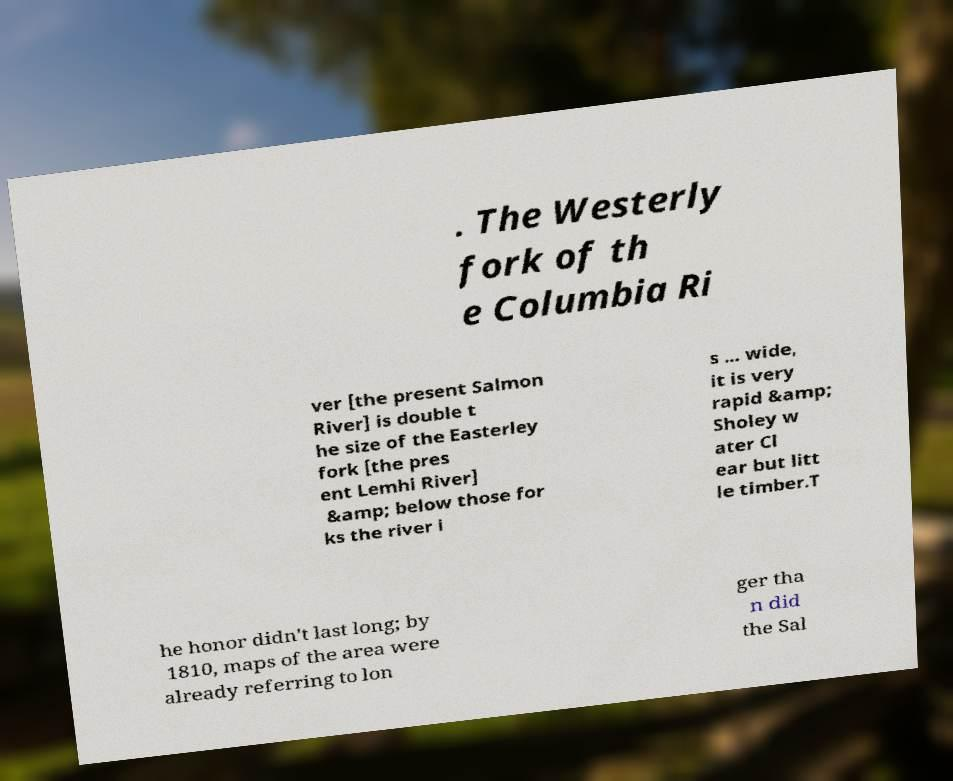Could you assist in decoding the text presented in this image and type it out clearly? . The Westerly fork of th e Columbia Ri ver [the present Salmon River] is double t he size of the Easterley fork [the pres ent Lemhi River] &amp; below those for ks the river i s ... wide, it is very rapid &amp; Sholey w ater Cl ear but litt le timber.T he honor didn't last long; by 1810, maps of the area were already referring to lon ger tha n did the Sal 